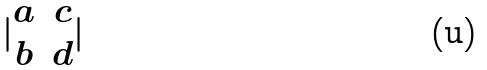Convert formula to latex. <formula><loc_0><loc_0><loc_500><loc_500>| \begin{matrix} a & c \\ b & d \end{matrix} |</formula> 